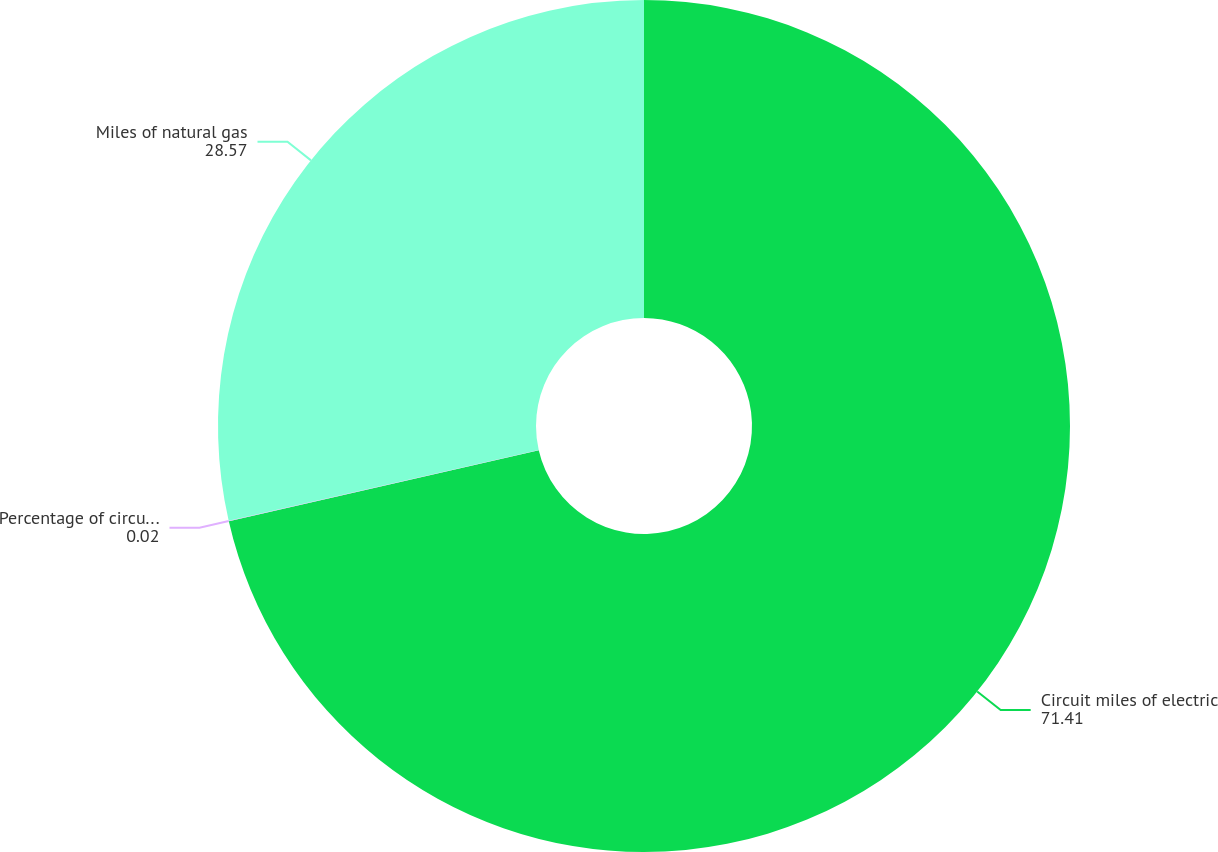Convert chart to OTSL. <chart><loc_0><loc_0><loc_500><loc_500><pie_chart><fcel>Circuit miles of electric<fcel>Percentage of circuit miles of<fcel>Miles of natural gas<nl><fcel>71.41%<fcel>0.02%<fcel>28.57%<nl></chart> 